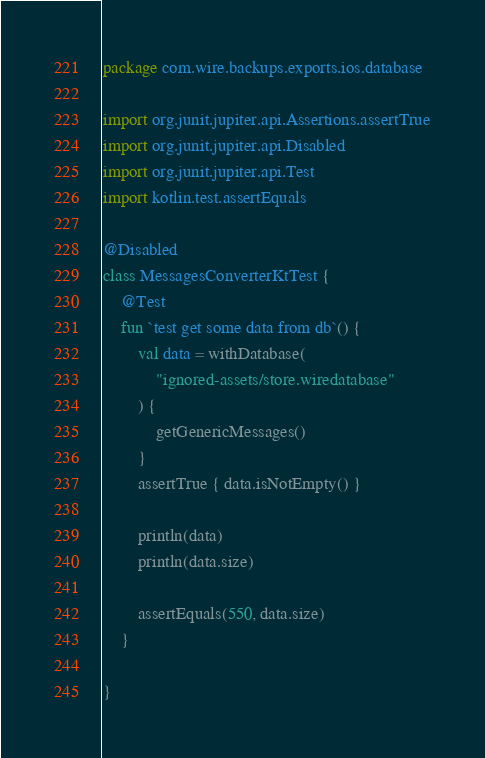Convert code to text. <code><loc_0><loc_0><loc_500><loc_500><_Kotlin_>package com.wire.backups.exports.ios.database

import org.junit.jupiter.api.Assertions.assertTrue
import org.junit.jupiter.api.Disabled
import org.junit.jupiter.api.Test
import kotlin.test.assertEquals

@Disabled
class MessagesConverterKtTest {
    @Test
    fun `test get some data from db`() {
        val data = withDatabase(
            "ignored-assets/store.wiredatabase"
        ) {
            getGenericMessages()
        }
        assertTrue { data.isNotEmpty() }

        println(data)
        println(data.size)

        assertEquals(550, data.size)
    }

}
</code> 